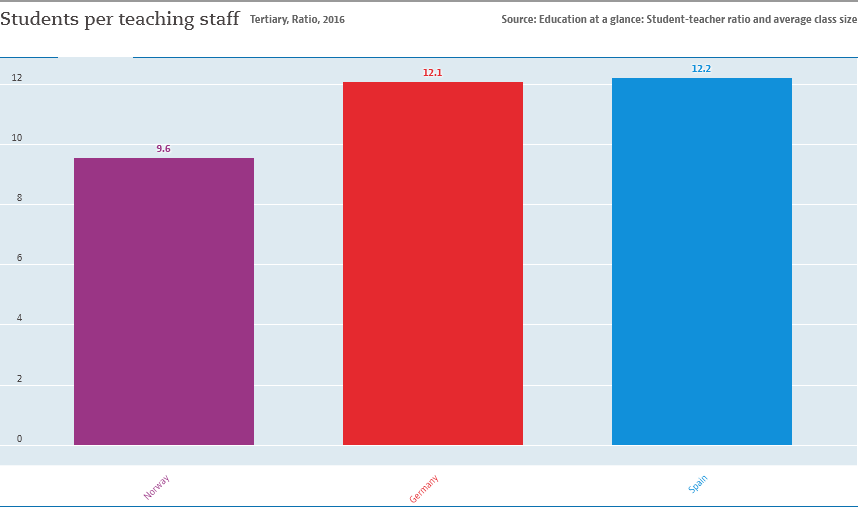Highlight a few significant elements in this photo. The y-axis represents the number of students per teaching staff in a school. After calculating the measures of central tendency, the median for the three countries is 23.4. 